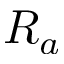Convert formula to latex. <formula><loc_0><loc_0><loc_500><loc_500>R _ { a }</formula> 